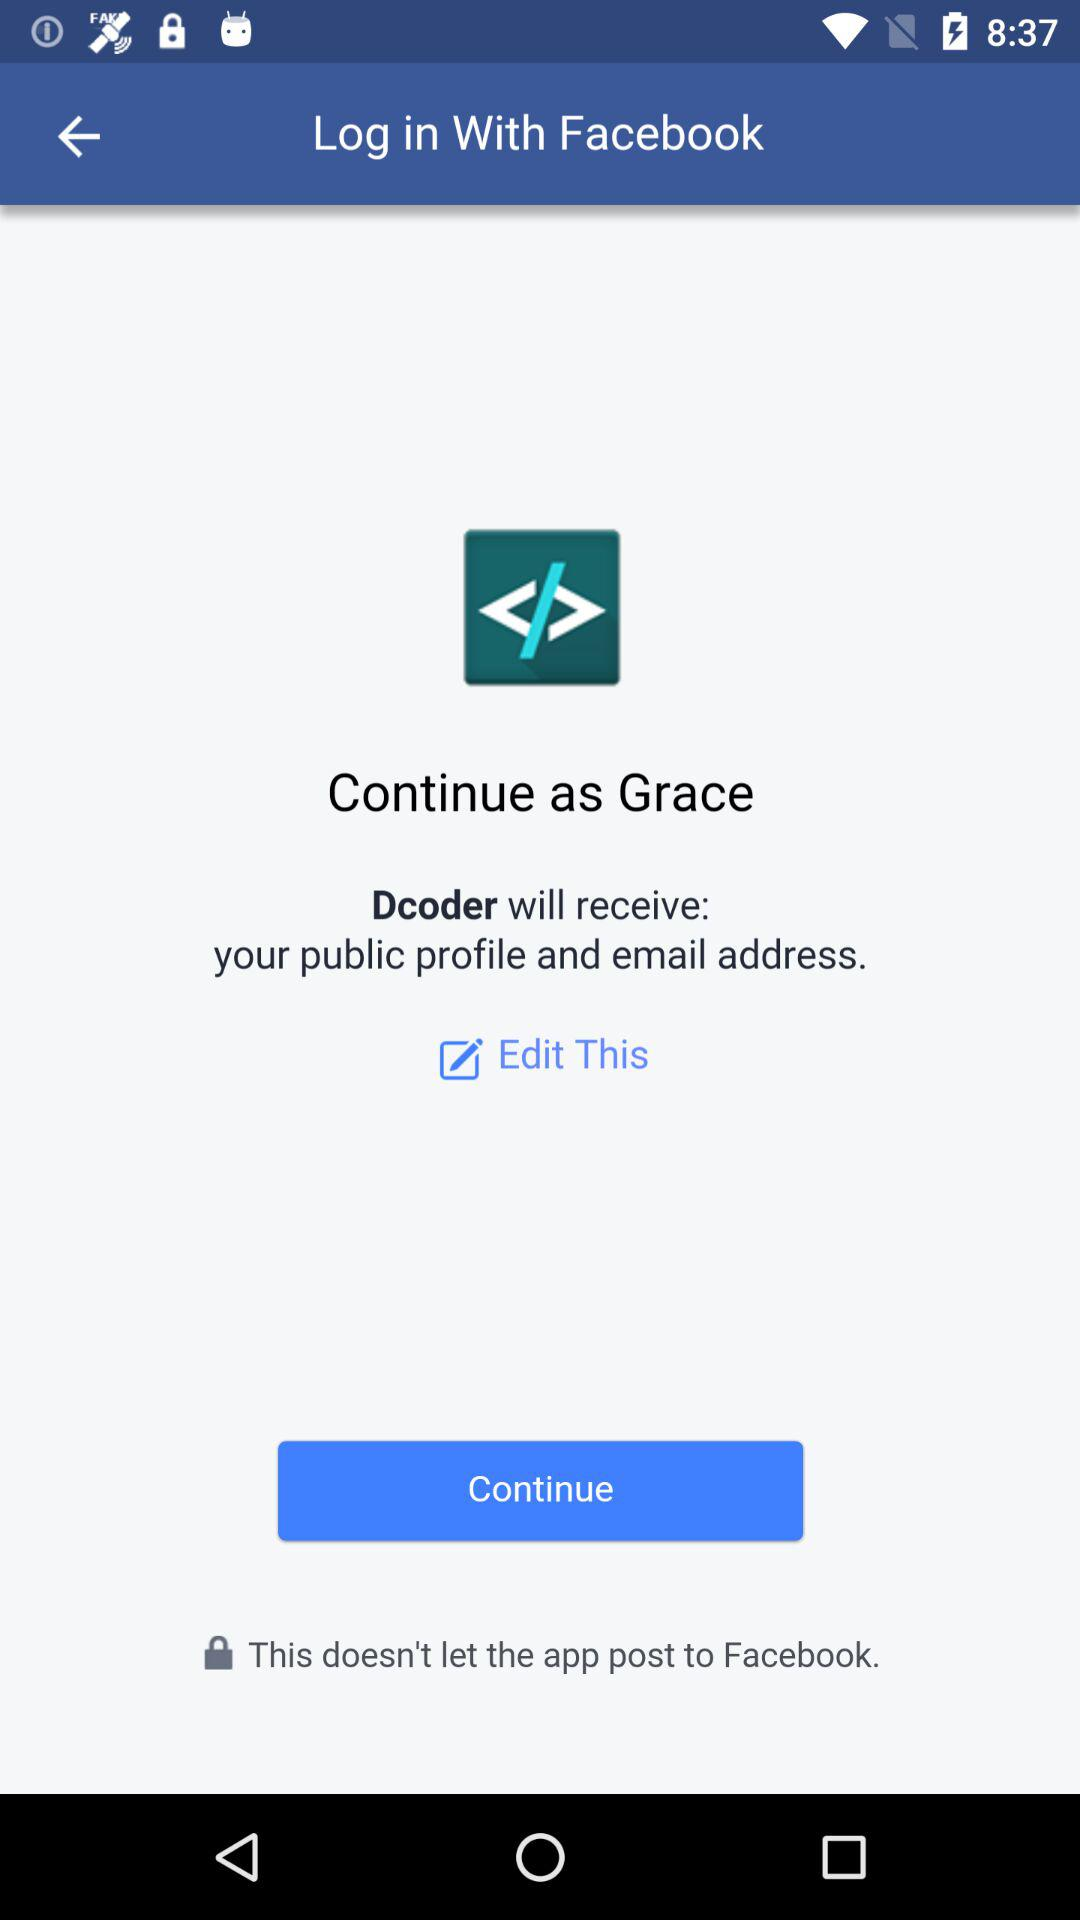What is the app name? The app name is "Dcoder". 